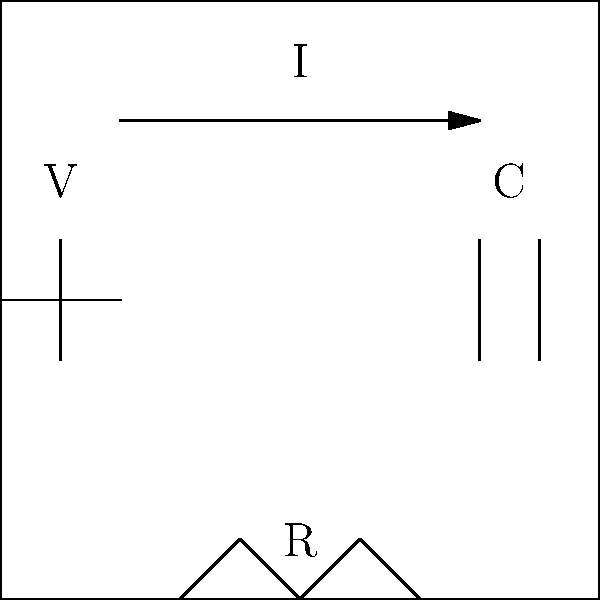In a simplified life support machine circuit, there's a voltage source V, a resistor R, and a capacitor C connected in series. If the voltage source provides 120 V, the resistor has a resistance of 1000 Ω, and the capacitor has a capacitance of 50 μF, what is the maximum charge stored in the capacitor when the circuit reaches steady state? To find the maximum charge stored in the capacitor, we'll follow these steps:

1. In a series circuit at steady state, the voltage across the capacitor (V_C) will be equal to the source voltage (V). This is because the current through a capacitor becomes zero at steady state, so there's no voltage drop across the resistor.

2. The relationship between charge (Q), capacitance (C), and voltage (V) for a capacitor is given by the equation:

   $Q = CV$

3. We're given:
   V = 120 V
   C = 50 μF = 50 x 10^(-6) F

4. Substituting these values into the equation:

   $Q = (50 x 10^{-6} F)(120 V)$

5. Calculating:

   $Q = 6 x 10^{-3} C$

6. Converting to microcoulombs:

   $Q = 6000 μC$

Therefore, the maximum charge stored in the capacitor when the circuit reaches steady state is 6000 μC.
Answer: 6000 μC 